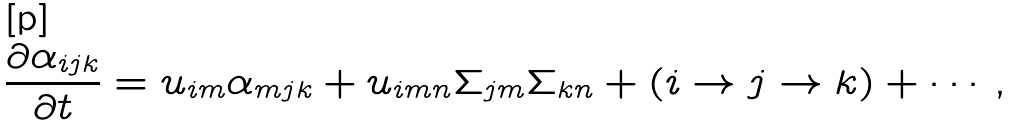Convert formula to latex. <formula><loc_0><loc_0><loc_500><loc_500>\frac { \partial \alpha _ { i j k } } { \partial t } = u _ { i m } \alpha _ { m j k } + u _ { i m n } \Sigma _ { j m } \Sigma _ { k n } + ( i \rightarrow j \rightarrow k ) + \cdots ,</formula> 